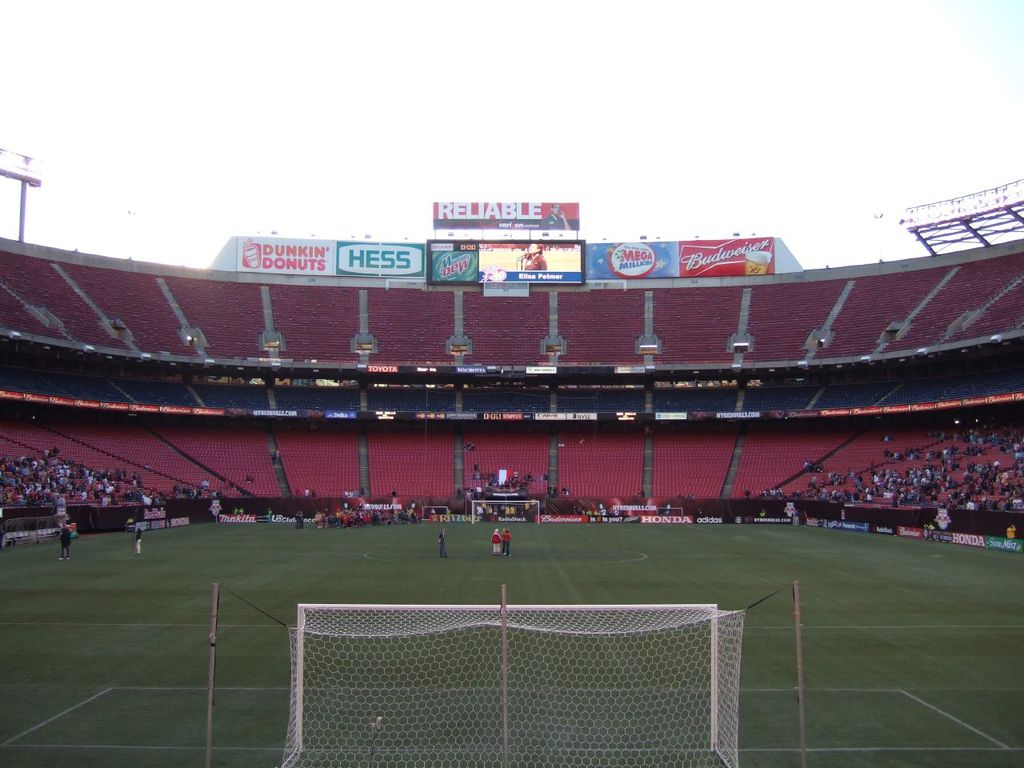Can you describe the mood or atmosphere of this stadium as shown in the image? The stadium appears partially filled with spectators and bathed in a warm, setting sun light, suggesting an engaging and lively atmosphere typical of sporting events. 